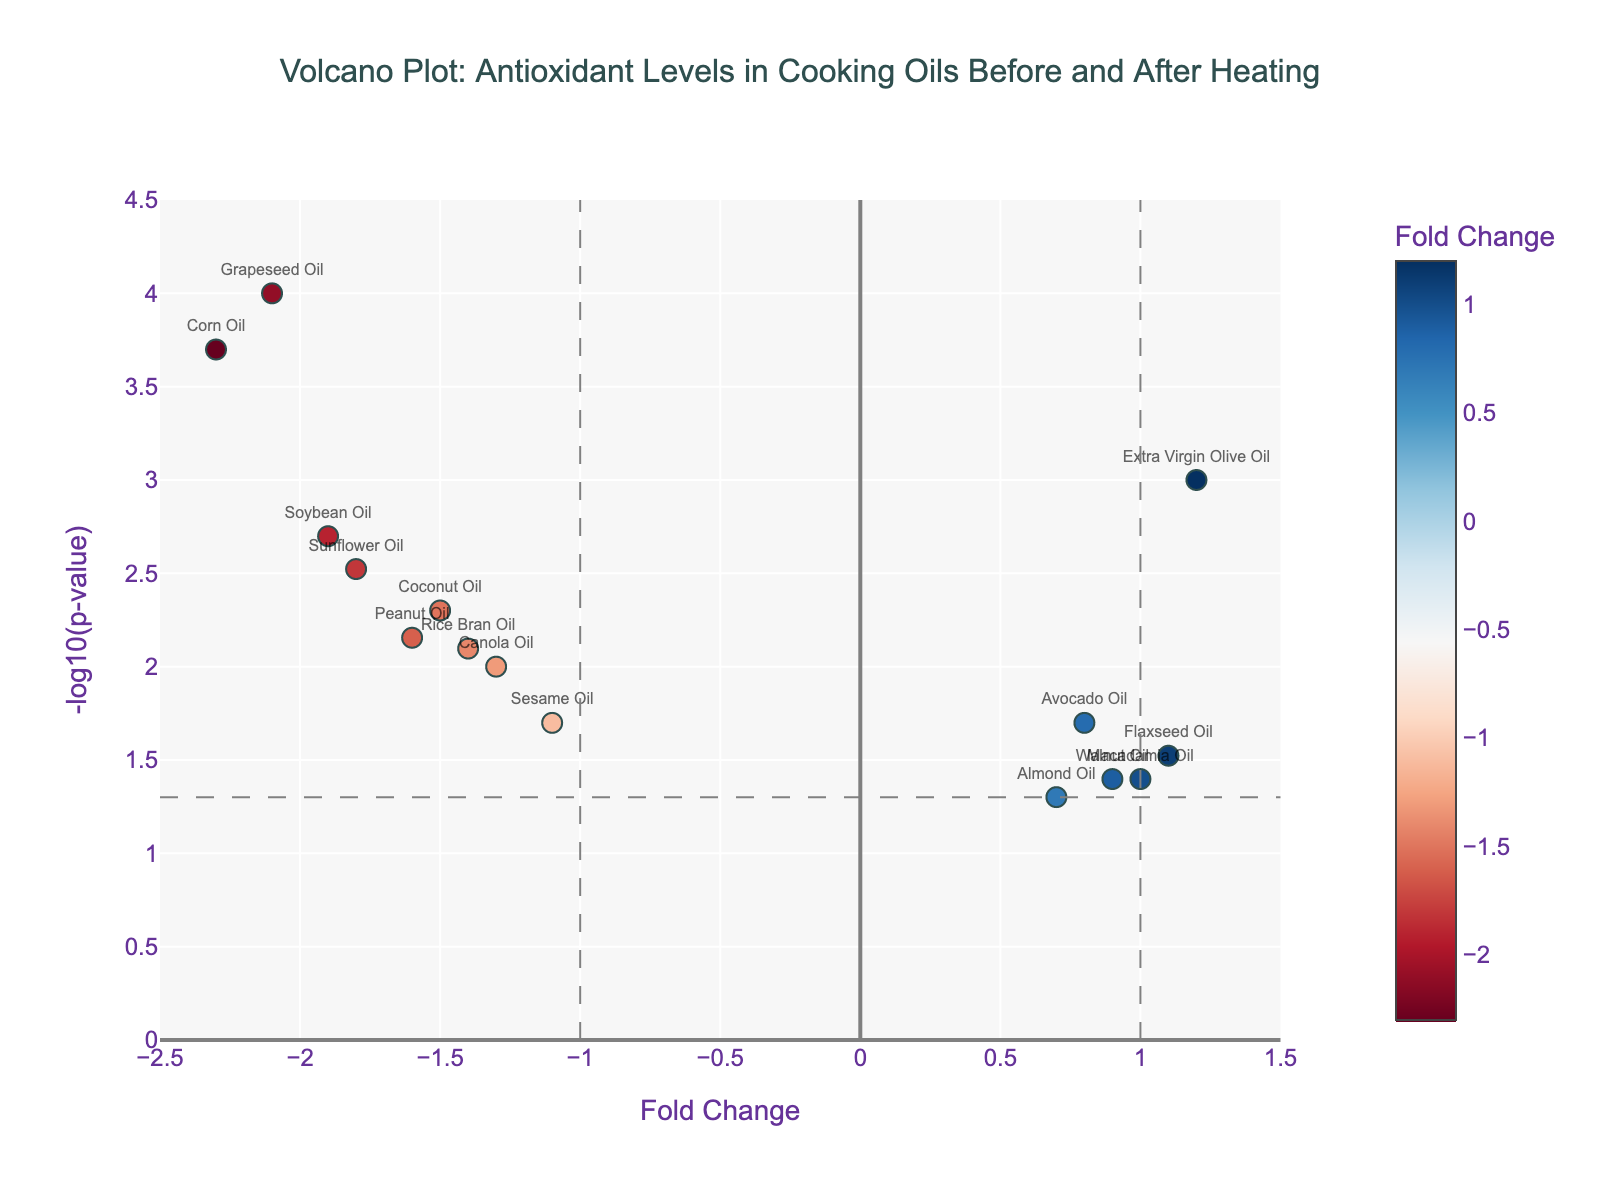What is the title of the volcano plot? The title can be found at the top of the plot, usually summarizing the overall purpose of the figure. Here, it reads "Volcano Plot: Antioxidant Levels in Cooking Oils Before and After Heating".
Answer: Volcano Plot: Antioxidant Levels in Cooking Oils Before and After Heating How many cooking oils are represented in the plot? Count the number of data points (each representing a cooking oil) shown in the figure.
Answer: 15 Which oil type has the highest fold change? Identify the oil with the largest fold change value on the x-axis.
Answer: Extra Virgin Olive Oil Which oil type has the smallest p-value? Identify the oil type that corresponds to the highest point on the y-axis, since smaller p-values are represented by larger -log10(p-value) values.
Answer: Grapeseed Oil What are the fold change and p-value for Corn Oil? Find Corn Oil on the plot to determine its approximate fold change on the x-axis and its p-value through the y-axis and -log10(p) conversion.
Answer: Fold Change: -2.3, p-value: 0.0002 How many oils have a fold change greater than 1 or less than -1? Count the number of data points that fall outside the range -1 < x < 1.
Answer: 7 Which oil types remain statistically significant after correcting for multiple testing with a threshold of p < 0.05? Identify the points above the horizontal line at -log10(0.05) ≈ 1.3, which signifies statistical significance.
Answer: Extra Virgin Olive Oil, Coconut Oil, Grapeseed Oil, Sunflower Oil, Canola Oil, Sesame Oil, Peanut Oil, Rice Bran Oil, Corn Oil, Soybean Oil What color scale is used to represent fold change? Observe the color representation of fold change values, where typically red and blue indicate different directions of fold change.
Answer: RdBu Which cooking oils show an increase in antioxidant levels after heating (positive fold change)? Identify the oils with positive fold change values on the x-axis.
Answer: Extra Virgin Olive Oil, Avocado Oil, Walnut Oil, Flaxseed Oil, Macadamia Oil, Almond Oil How does Coconut Oil compare to Canola Oil in terms of fold change and significance? Compare their fold change values on the x-axis and their y-axis positions indicating significance (-log10(p-value)).
Answer: Coconut Oil: Fold Change: -1.5, p-value: 0.005; Canola Oil: Fold Change: -1.3, p-value: 0.01 